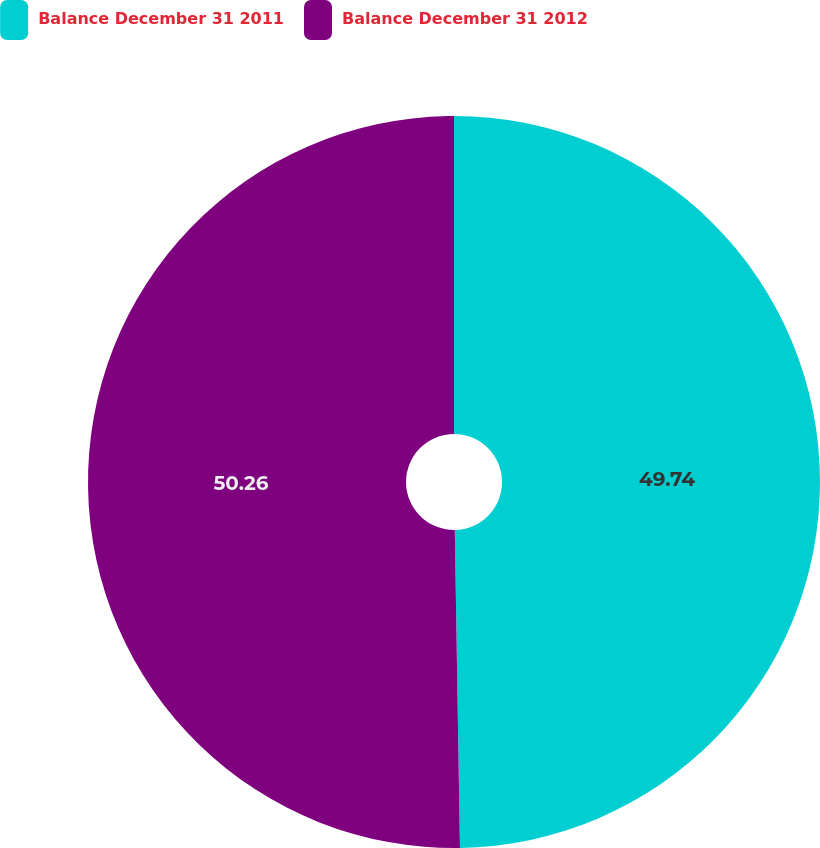Convert chart to OTSL. <chart><loc_0><loc_0><loc_500><loc_500><pie_chart><fcel>Balance December 31 2011<fcel>Balance December 31 2012<nl><fcel>49.74%<fcel>50.26%<nl></chart> 